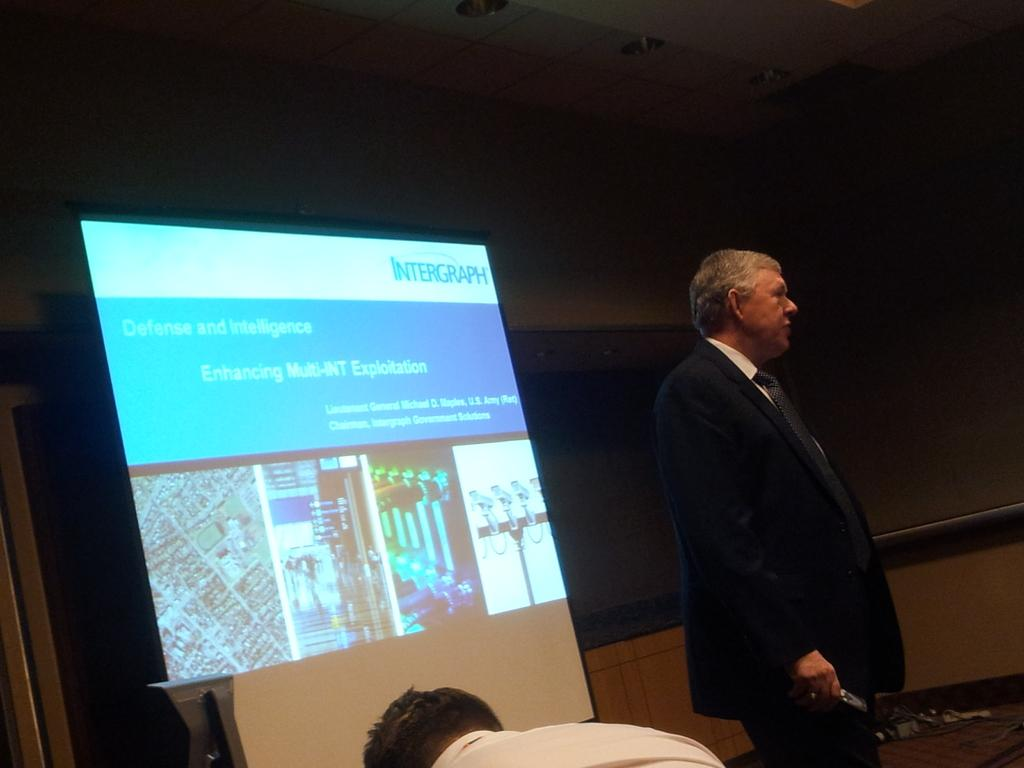How many people are present in the image? There are two people in the image, one standing and one sitting. What is the position of the person in the image? The person standing is standing, and the person sitting is sitting. What can be seen on the screen in the image? The facts do not specify what is visible on the screen. What type of dinosaurs can be seen walking in the background of the image? There are no dinosaurs present in the image. Is the person in the image's dad? The facts do not provide any information about the relationship between the person in the image and anyone else. 